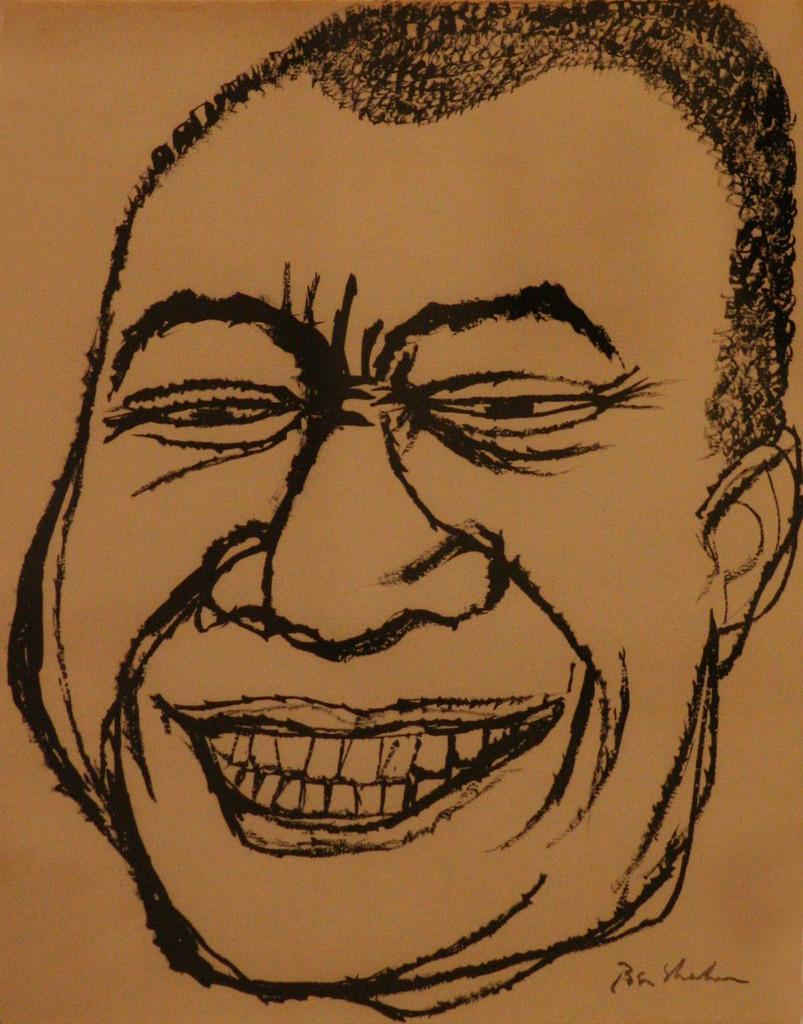Could you give a brief overview of what you see in this image? In this image I can see an art of a person face on the paper and the art is in black color. 